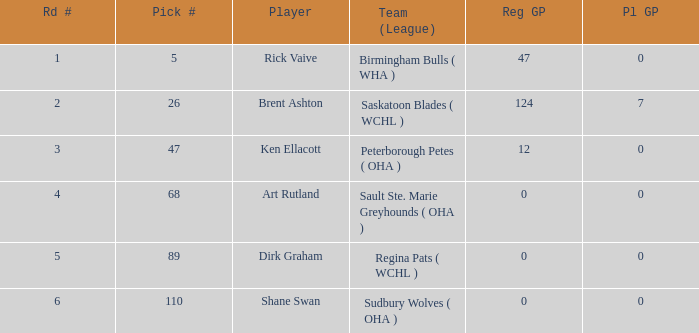How many rounds exist for picks under 5? 0.0. 